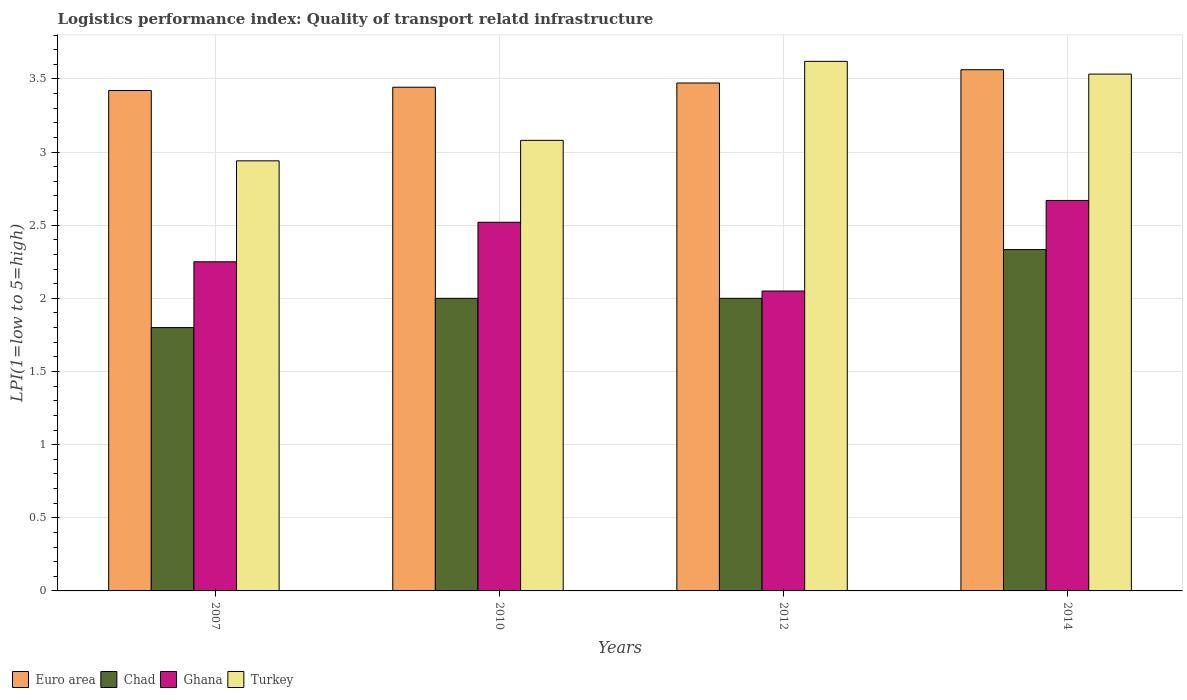How many different coloured bars are there?
Your answer should be compact. 4. Are the number of bars on each tick of the X-axis equal?
Offer a terse response. Yes. How many bars are there on the 4th tick from the left?
Offer a terse response. 4. What is the label of the 4th group of bars from the left?
Your response must be concise. 2014. What is the logistics performance index in Ghana in 2010?
Offer a terse response. 2.52. Across all years, what is the maximum logistics performance index in Euro area?
Offer a very short reply. 3.56. What is the total logistics performance index in Chad in the graph?
Provide a short and direct response. 8.13. What is the difference between the logistics performance index in Ghana in 2010 and that in 2012?
Give a very brief answer. 0.47. What is the difference between the logistics performance index in Euro area in 2007 and the logistics performance index in Turkey in 2010?
Offer a very short reply. 0.34. What is the average logistics performance index in Euro area per year?
Offer a very short reply. 3.47. In the year 2007, what is the difference between the logistics performance index in Chad and logistics performance index in Turkey?
Make the answer very short. -1.14. Is the logistics performance index in Chad in 2007 less than that in 2014?
Make the answer very short. Yes. What is the difference between the highest and the second highest logistics performance index in Turkey?
Provide a succinct answer. 0.09. What is the difference between the highest and the lowest logistics performance index in Euro area?
Your answer should be very brief. 0.14. What does the 2nd bar from the left in 2014 represents?
Your answer should be compact. Chad. What does the 3rd bar from the right in 2012 represents?
Offer a very short reply. Chad. How many bars are there?
Provide a succinct answer. 16. Are all the bars in the graph horizontal?
Offer a terse response. No. What is the difference between two consecutive major ticks on the Y-axis?
Provide a short and direct response. 0.5. Does the graph contain grids?
Keep it short and to the point. Yes. Where does the legend appear in the graph?
Provide a succinct answer. Bottom left. How are the legend labels stacked?
Your response must be concise. Horizontal. What is the title of the graph?
Your answer should be compact. Logistics performance index: Quality of transport relatd infrastructure. What is the label or title of the X-axis?
Your answer should be compact. Years. What is the label or title of the Y-axis?
Your answer should be very brief. LPI(1=low to 5=high). What is the LPI(1=low to 5=high) of Euro area in 2007?
Provide a short and direct response. 3.42. What is the LPI(1=low to 5=high) in Chad in 2007?
Your answer should be compact. 1.8. What is the LPI(1=low to 5=high) of Ghana in 2007?
Provide a succinct answer. 2.25. What is the LPI(1=low to 5=high) in Turkey in 2007?
Ensure brevity in your answer.  2.94. What is the LPI(1=low to 5=high) in Euro area in 2010?
Ensure brevity in your answer.  3.44. What is the LPI(1=low to 5=high) in Chad in 2010?
Give a very brief answer. 2. What is the LPI(1=low to 5=high) of Ghana in 2010?
Make the answer very short. 2.52. What is the LPI(1=low to 5=high) in Turkey in 2010?
Give a very brief answer. 3.08. What is the LPI(1=low to 5=high) in Euro area in 2012?
Provide a short and direct response. 3.47. What is the LPI(1=low to 5=high) of Chad in 2012?
Ensure brevity in your answer.  2. What is the LPI(1=low to 5=high) of Ghana in 2012?
Provide a short and direct response. 2.05. What is the LPI(1=low to 5=high) in Turkey in 2012?
Make the answer very short. 3.62. What is the LPI(1=low to 5=high) in Euro area in 2014?
Your answer should be compact. 3.56. What is the LPI(1=low to 5=high) in Chad in 2014?
Your response must be concise. 2.33. What is the LPI(1=low to 5=high) in Ghana in 2014?
Offer a very short reply. 2.67. What is the LPI(1=low to 5=high) of Turkey in 2014?
Keep it short and to the point. 3.53. Across all years, what is the maximum LPI(1=low to 5=high) in Euro area?
Your response must be concise. 3.56. Across all years, what is the maximum LPI(1=low to 5=high) in Chad?
Provide a succinct answer. 2.33. Across all years, what is the maximum LPI(1=low to 5=high) in Ghana?
Keep it short and to the point. 2.67. Across all years, what is the maximum LPI(1=low to 5=high) of Turkey?
Make the answer very short. 3.62. Across all years, what is the minimum LPI(1=low to 5=high) in Euro area?
Offer a very short reply. 3.42. Across all years, what is the minimum LPI(1=low to 5=high) in Chad?
Provide a short and direct response. 1.8. Across all years, what is the minimum LPI(1=low to 5=high) in Ghana?
Your answer should be very brief. 2.05. Across all years, what is the minimum LPI(1=low to 5=high) of Turkey?
Your answer should be very brief. 2.94. What is the total LPI(1=low to 5=high) in Euro area in the graph?
Give a very brief answer. 13.9. What is the total LPI(1=low to 5=high) of Chad in the graph?
Offer a terse response. 8.13. What is the total LPI(1=low to 5=high) in Ghana in the graph?
Your answer should be compact. 9.49. What is the total LPI(1=low to 5=high) of Turkey in the graph?
Ensure brevity in your answer.  13.17. What is the difference between the LPI(1=low to 5=high) in Euro area in 2007 and that in 2010?
Offer a terse response. -0.02. What is the difference between the LPI(1=low to 5=high) of Ghana in 2007 and that in 2010?
Your answer should be very brief. -0.27. What is the difference between the LPI(1=low to 5=high) of Turkey in 2007 and that in 2010?
Give a very brief answer. -0.14. What is the difference between the LPI(1=low to 5=high) of Euro area in 2007 and that in 2012?
Provide a succinct answer. -0.05. What is the difference between the LPI(1=low to 5=high) in Chad in 2007 and that in 2012?
Provide a succinct answer. -0.2. What is the difference between the LPI(1=low to 5=high) of Ghana in 2007 and that in 2012?
Keep it short and to the point. 0.2. What is the difference between the LPI(1=low to 5=high) in Turkey in 2007 and that in 2012?
Give a very brief answer. -0.68. What is the difference between the LPI(1=low to 5=high) in Euro area in 2007 and that in 2014?
Provide a succinct answer. -0.14. What is the difference between the LPI(1=low to 5=high) in Chad in 2007 and that in 2014?
Provide a succinct answer. -0.53. What is the difference between the LPI(1=low to 5=high) in Ghana in 2007 and that in 2014?
Make the answer very short. -0.42. What is the difference between the LPI(1=low to 5=high) of Turkey in 2007 and that in 2014?
Keep it short and to the point. -0.59. What is the difference between the LPI(1=low to 5=high) in Euro area in 2010 and that in 2012?
Keep it short and to the point. -0.03. What is the difference between the LPI(1=low to 5=high) of Ghana in 2010 and that in 2012?
Provide a short and direct response. 0.47. What is the difference between the LPI(1=low to 5=high) of Turkey in 2010 and that in 2012?
Your answer should be compact. -0.54. What is the difference between the LPI(1=low to 5=high) in Euro area in 2010 and that in 2014?
Make the answer very short. -0.12. What is the difference between the LPI(1=low to 5=high) of Chad in 2010 and that in 2014?
Offer a very short reply. -0.33. What is the difference between the LPI(1=low to 5=high) in Ghana in 2010 and that in 2014?
Your answer should be very brief. -0.15. What is the difference between the LPI(1=low to 5=high) in Turkey in 2010 and that in 2014?
Ensure brevity in your answer.  -0.45. What is the difference between the LPI(1=low to 5=high) of Euro area in 2012 and that in 2014?
Offer a terse response. -0.09. What is the difference between the LPI(1=low to 5=high) of Chad in 2012 and that in 2014?
Your answer should be compact. -0.33. What is the difference between the LPI(1=low to 5=high) of Ghana in 2012 and that in 2014?
Ensure brevity in your answer.  -0.62. What is the difference between the LPI(1=low to 5=high) in Turkey in 2012 and that in 2014?
Provide a succinct answer. 0.09. What is the difference between the LPI(1=low to 5=high) in Euro area in 2007 and the LPI(1=low to 5=high) in Chad in 2010?
Your answer should be very brief. 1.42. What is the difference between the LPI(1=low to 5=high) of Euro area in 2007 and the LPI(1=low to 5=high) of Ghana in 2010?
Give a very brief answer. 0.9. What is the difference between the LPI(1=low to 5=high) of Euro area in 2007 and the LPI(1=low to 5=high) of Turkey in 2010?
Your answer should be very brief. 0.34. What is the difference between the LPI(1=low to 5=high) of Chad in 2007 and the LPI(1=low to 5=high) of Ghana in 2010?
Your answer should be very brief. -0.72. What is the difference between the LPI(1=low to 5=high) of Chad in 2007 and the LPI(1=low to 5=high) of Turkey in 2010?
Ensure brevity in your answer.  -1.28. What is the difference between the LPI(1=low to 5=high) of Ghana in 2007 and the LPI(1=low to 5=high) of Turkey in 2010?
Offer a very short reply. -0.83. What is the difference between the LPI(1=low to 5=high) in Euro area in 2007 and the LPI(1=low to 5=high) in Chad in 2012?
Give a very brief answer. 1.42. What is the difference between the LPI(1=low to 5=high) of Euro area in 2007 and the LPI(1=low to 5=high) of Ghana in 2012?
Your answer should be compact. 1.37. What is the difference between the LPI(1=low to 5=high) in Euro area in 2007 and the LPI(1=low to 5=high) in Turkey in 2012?
Make the answer very short. -0.2. What is the difference between the LPI(1=low to 5=high) of Chad in 2007 and the LPI(1=low to 5=high) of Ghana in 2012?
Your answer should be compact. -0.25. What is the difference between the LPI(1=low to 5=high) of Chad in 2007 and the LPI(1=low to 5=high) of Turkey in 2012?
Your answer should be very brief. -1.82. What is the difference between the LPI(1=low to 5=high) in Ghana in 2007 and the LPI(1=low to 5=high) in Turkey in 2012?
Make the answer very short. -1.37. What is the difference between the LPI(1=low to 5=high) in Euro area in 2007 and the LPI(1=low to 5=high) in Chad in 2014?
Offer a very short reply. 1.09. What is the difference between the LPI(1=low to 5=high) of Euro area in 2007 and the LPI(1=low to 5=high) of Ghana in 2014?
Offer a terse response. 0.75. What is the difference between the LPI(1=low to 5=high) in Euro area in 2007 and the LPI(1=low to 5=high) in Turkey in 2014?
Offer a terse response. -0.11. What is the difference between the LPI(1=low to 5=high) in Chad in 2007 and the LPI(1=low to 5=high) in Ghana in 2014?
Ensure brevity in your answer.  -0.87. What is the difference between the LPI(1=low to 5=high) in Chad in 2007 and the LPI(1=low to 5=high) in Turkey in 2014?
Your response must be concise. -1.73. What is the difference between the LPI(1=low to 5=high) of Ghana in 2007 and the LPI(1=low to 5=high) of Turkey in 2014?
Give a very brief answer. -1.28. What is the difference between the LPI(1=low to 5=high) in Euro area in 2010 and the LPI(1=low to 5=high) in Chad in 2012?
Your response must be concise. 1.44. What is the difference between the LPI(1=low to 5=high) in Euro area in 2010 and the LPI(1=low to 5=high) in Ghana in 2012?
Your answer should be compact. 1.39. What is the difference between the LPI(1=low to 5=high) of Euro area in 2010 and the LPI(1=low to 5=high) of Turkey in 2012?
Give a very brief answer. -0.18. What is the difference between the LPI(1=low to 5=high) of Chad in 2010 and the LPI(1=low to 5=high) of Ghana in 2012?
Ensure brevity in your answer.  -0.05. What is the difference between the LPI(1=low to 5=high) of Chad in 2010 and the LPI(1=low to 5=high) of Turkey in 2012?
Your response must be concise. -1.62. What is the difference between the LPI(1=low to 5=high) in Ghana in 2010 and the LPI(1=low to 5=high) in Turkey in 2012?
Make the answer very short. -1.1. What is the difference between the LPI(1=low to 5=high) of Euro area in 2010 and the LPI(1=low to 5=high) of Chad in 2014?
Provide a short and direct response. 1.11. What is the difference between the LPI(1=low to 5=high) of Euro area in 2010 and the LPI(1=low to 5=high) of Ghana in 2014?
Ensure brevity in your answer.  0.77. What is the difference between the LPI(1=low to 5=high) of Euro area in 2010 and the LPI(1=low to 5=high) of Turkey in 2014?
Your response must be concise. -0.09. What is the difference between the LPI(1=low to 5=high) of Chad in 2010 and the LPI(1=low to 5=high) of Ghana in 2014?
Keep it short and to the point. -0.67. What is the difference between the LPI(1=low to 5=high) of Chad in 2010 and the LPI(1=low to 5=high) of Turkey in 2014?
Make the answer very short. -1.53. What is the difference between the LPI(1=low to 5=high) of Ghana in 2010 and the LPI(1=low to 5=high) of Turkey in 2014?
Make the answer very short. -1.01. What is the difference between the LPI(1=low to 5=high) of Euro area in 2012 and the LPI(1=low to 5=high) of Chad in 2014?
Your response must be concise. 1.14. What is the difference between the LPI(1=low to 5=high) in Euro area in 2012 and the LPI(1=low to 5=high) in Ghana in 2014?
Ensure brevity in your answer.  0.8. What is the difference between the LPI(1=low to 5=high) in Euro area in 2012 and the LPI(1=low to 5=high) in Turkey in 2014?
Make the answer very short. -0.06. What is the difference between the LPI(1=low to 5=high) in Chad in 2012 and the LPI(1=low to 5=high) in Ghana in 2014?
Offer a very short reply. -0.67. What is the difference between the LPI(1=low to 5=high) of Chad in 2012 and the LPI(1=low to 5=high) of Turkey in 2014?
Provide a short and direct response. -1.53. What is the difference between the LPI(1=low to 5=high) of Ghana in 2012 and the LPI(1=low to 5=high) of Turkey in 2014?
Make the answer very short. -1.48. What is the average LPI(1=low to 5=high) of Euro area per year?
Your answer should be very brief. 3.47. What is the average LPI(1=low to 5=high) of Chad per year?
Offer a very short reply. 2.03. What is the average LPI(1=low to 5=high) in Ghana per year?
Provide a short and direct response. 2.37. What is the average LPI(1=low to 5=high) in Turkey per year?
Your answer should be compact. 3.29. In the year 2007, what is the difference between the LPI(1=low to 5=high) in Euro area and LPI(1=low to 5=high) in Chad?
Offer a very short reply. 1.62. In the year 2007, what is the difference between the LPI(1=low to 5=high) of Euro area and LPI(1=low to 5=high) of Ghana?
Give a very brief answer. 1.17. In the year 2007, what is the difference between the LPI(1=low to 5=high) of Euro area and LPI(1=low to 5=high) of Turkey?
Give a very brief answer. 0.48. In the year 2007, what is the difference between the LPI(1=low to 5=high) in Chad and LPI(1=low to 5=high) in Ghana?
Your answer should be compact. -0.45. In the year 2007, what is the difference between the LPI(1=low to 5=high) in Chad and LPI(1=low to 5=high) in Turkey?
Offer a very short reply. -1.14. In the year 2007, what is the difference between the LPI(1=low to 5=high) in Ghana and LPI(1=low to 5=high) in Turkey?
Provide a short and direct response. -0.69. In the year 2010, what is the difference between the LPI(1=low to 5=high) of Euro area and LPI(1=low to 5=high) of Chad?
Ensure brevity in your answer.  1.44. In the year 2010, what is the difference between the LPI(1=low to 5=high) in Euro area and LPI(1=low to 5=high) in Ghana?
Make the answer very short. 0.92. In the year 2010, what is the difference between the LPI(1=low to 5=high) in Euro area and LPI(1=low to 5=high) in Turkey?
Provide a short and direct response. 0.36. In the year 2010, what is the difference between the LPI(1=low to 5=high) of Chad and LPI(1=low to 5=high) of Ghana?
Offer a very short reply. -0.52. In the year 2010, what is the difference between the LPI(1=low to 5=high) of Chad and LPI(1=low to 5=high) of Turkey?
Your response must be concise. -1.08. In the year 2010, what is the difference between the LPI(1=low to 5=high) of Ghana and LPI(1=low to 5=high) of Turkey?
Your answer should be compact. -0.56. In the year 2012, what is the difference between the LPI(1=low to 5=high) in Euro area and LPI(1=low to 5=high) in Chad?
Ensure brevity in your answer.  1.47. In the year 2012, what is the difference between the LPI(1=low to 5=high) of Euro area and LPI(1=low to 5=high) of Ghana?
Offer a terse response. 1.42. In the year 2012, what is the difference between the LPI(1=low to 5=high) of Euro area and LPI(1=low to 5=high) of Turkey?
Make the answer very short. -0.15. In the year 2012, what is the difference between the LPI(1=low to 5=high) of Chad and LPI(1=low to 5=high) of Ghana?
Provide a succinct answer. -0.05. In the year 2012, what is the difference between the LPI(1=low to 5=high) in Chad and LPI(1=low to 5=high) in Turkey?
Your response must be concise. -1.62. In the year 2012, what is the difference between the LPI(1=low to 5=high) in Ghana and LPI(1=low to 5=high) in Turkey?
Your response must be concise. -1.57. In the year 2014, what is the difference between the LPI(1=low to 5=high) in Euro area and LPI(1=low to 5=high) in Chad?
Offer a very short reply. 1.23. In the year 2014, what is the difference between the LPI(1=low to 5=high) in Euro area and LPI(1=low to 5=high) in Ghana?
Your answer should be very brief. 0.89. In the year 2014, what is the difference between the LPI(1=low to 5=high) of Euro area and LPI(1=low to 5=high) of Turkey?
Provide a short and direct response. 0.03. In the year 2014, what is the difference between the LPI(1=low to 5=high) of Chad and LPI(1=low to 5=high) of Ghana?
Provide a short and direct response. -0.34. In the year 2014, what is the difference between the LPI(1=low to 5=high) of Chad and LPI(1=low to 5=high) of Turkey?
Provide a succinct answer. -1.2. In the year 2014, what is the difference between the LPI(1=low to 5=high) in Ghana and LPI(1=low to 5=high) in Turkey?
Your response must be concise. -0.86. What is the ratio of the LPI(1=low to 5=high) of Euro area in 2007 to that in 2010?
Your answer should be very brief. 0.99. What is the ratio of the LPI(1=low to 5=high) of Ghana in 2007 to that in 2010?
Keep it short and to the point. 0.89. What is the ratio of the LPI(1=low to 5=high) in Turkey in 2007 to that in 2010?
Offer a very short reply. 0.95. What is the ratio of the LPI(1=low to 5=high) of Euro area in 2007 to that in 2012?
Give a very brief answer. 0.99. What is the ratio of the LPI(1=low to 5=high) of Ghana in 2007 to that in 2012?
Offer a terse response. 1.1. What is the ratio of the LPI(1=low to 5=high) in Turkey in 2007 to that in 2012?
Provide a short and direct response. 0.81. What is the ratio of the LPI(1=low to 5=high) of Euro area in 2007 to that in 2014?
Provide a short and direct response. 0.96. What is the ratio of the LPI(1=low to 5=high) of Chad in 2007 to that in 2014?
Ensure brevity in your answer.  0.77. What is the ratio of the LPI(1=low to 5=high) of Ghana in 2007 to that in 2014?
Your answer should be compact. 0.84. What is the ratio of the LPI(1=low to 5=high) of Turkey in 2007 to that in 2014?
Provide a short and direct response. 0.83. What is the ratio of the LPI(1=low to 5=high) in Ghana in 2010 to that in 2012?
Offer a very short reply. 1.23. What is the ratio of the LPI(1=low to 5=high) in Turkey in 2010 to that in 2012?
Provide a short and direct response. 0.85. What is the ratio of the LPI(1=low to 5=high) in Euro area in 2010 to that in 2014?
Offer a terse response. 0.97. What is the ratio of the LPI(1=low to 5=high) of Chad in 2010 to that in 2014?
Give a very brief answer. 0.86. What is the ratio of the LPI(1=low to 5=high) in Ghana in 2010 to that in 2014?
Keep it short and to the point. 0.94. What is the ratio of the LPI(1=low to 5=high) in Turkey in 2010 to that in 2014?
Your answer should be compact. 0.87. What is the ratio of the LPI(1=low to 5=high) of Euro area in 2012 to that in 2014?
Keep it short and to the point. 0.97. What is the ratio of the LPI(1=low to 5=high) of Chad in 2012 to that in 2014?
Your answer should be very brief. 0.86. What is the ratio of the LPI(1=low to 5=high) of Ghana in 2012 to that in 2014?
Ensure brevity in your answer.  0.77. What is the ratio of the LPI(1=low to 5=high) of Turkey in 2012 to that in 2014?
Your answer should be very brief. 1.02. What is the difference between the highest and the second highest LPI(1=low to 5=high) in Euro area?
Make the answer very short. 0.09. What is the difference between the highest and the second highest LPI(1=low to 5=high) of Chad?
Your answer should be very brief. 0.33. What is the difference between the highest and the second highest LPI(1=low to 5=high) in Ghana?
Offer a very short reply. 0.15. What is the difference between the highest and the second highest LPI(1=low to 5=high) in Turkey?
Give a very brief answer. 0.09. What is the difference between the highest and the lowest LPI(1=low to 5=high) of Euro area?
Provide a short and direct response. 0.14. What is the difference between the highest and the lowest LPI(1=low to 5=high) in Chad?
Keep it short and to the point. 0.53. What is the difference between the highest and the lowest LPI(1=low to 5=high) in Ghana?
Your answer should be very brief. 0.62. What is the difference between the highest and the lowest LPI(1=low to 5=high) in Turkey?
Your answer should be very brief. 0.68. 